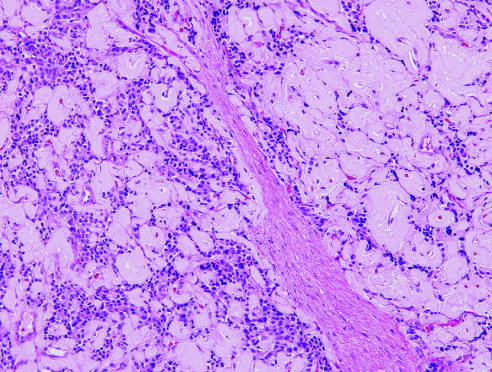s there abundant amyloid deposition, characteristic of an insulinoma?
Answer the question using a single word or phrase. Yes 